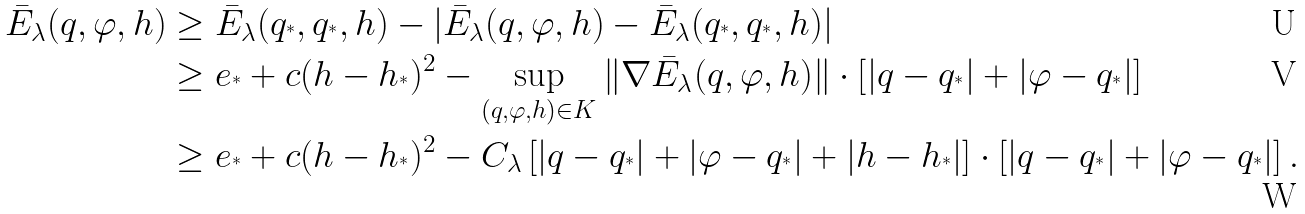Convert formula to latex. <formula><loc_0><loc_0><loc_500><loc_500>\bar { E } _ { \lambda } ( q , \varphi , h ) & \geq \bar { E } _ { \lambda } ( q _ { ^ { * } } , q _ { ^ { * } } , h ) - | \bar { E } _ { \lambda } ( q , \varphi , h ) - \bar { E } _ { \lambda } ( q _ { ^ { * } } , q _ { ^ { * } } , h ) | \\ & \geq e _ { ^ { * } } + c ( h - h _ { ^ { * } } ) ^ { 2 } - \sup _ { ( q , \varphi , h ) \in K } \| \nabla \bar { E } _ { \lambda } ( q , \varphi , h ) \| \cdot \left [ | q - q _ { ^ { * } } | + | \varphi - q _ { ^ { * } } | \right ] \\ & \geq e _ { ^ { * } } + c ( h - h _ { ^ { * } } ) ^ { 2 } - C _ { \lambda } \left [ | q - q _ { ^ { * } } | + | \varphi - q _ { ^ { * } } | + | h - h _ { ^ { * } } | \right ] \cdot \left [ | q - q _ { ^ { * } } | + | \varphi - q _ { ^ { * } } | \right ] .</formula> 